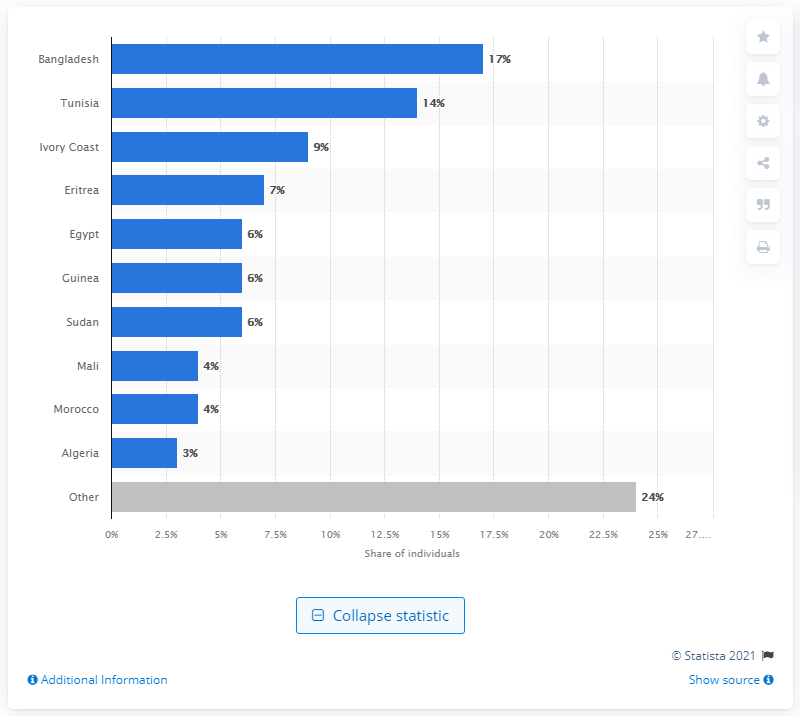Draw attention to some important aspects in this diagram. The most common country of origin declared upon arrival in Italy between January 1st and May 4th, 2021 was Bangladesh. 